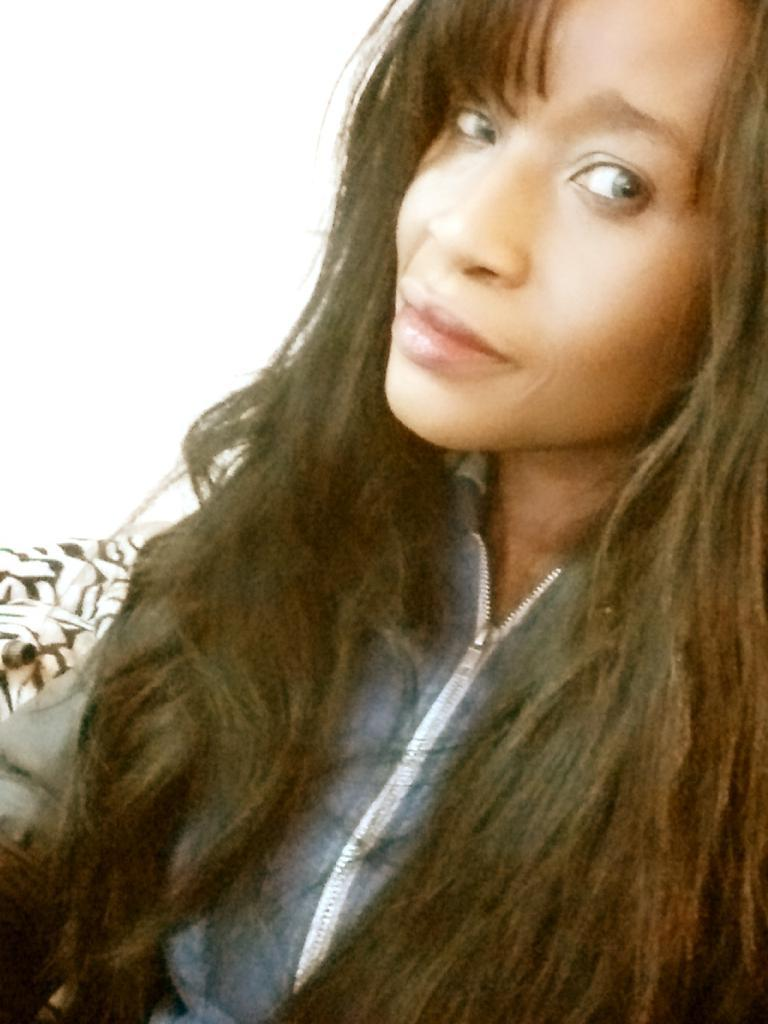What is the main subject of the image? There is a lady in the image. Can you describe the lady's appearance? The lady has long hair. What level of expertise does the lady have in the field of engineering? There is no information about the lady's expertise in the field of engineering in the image. 